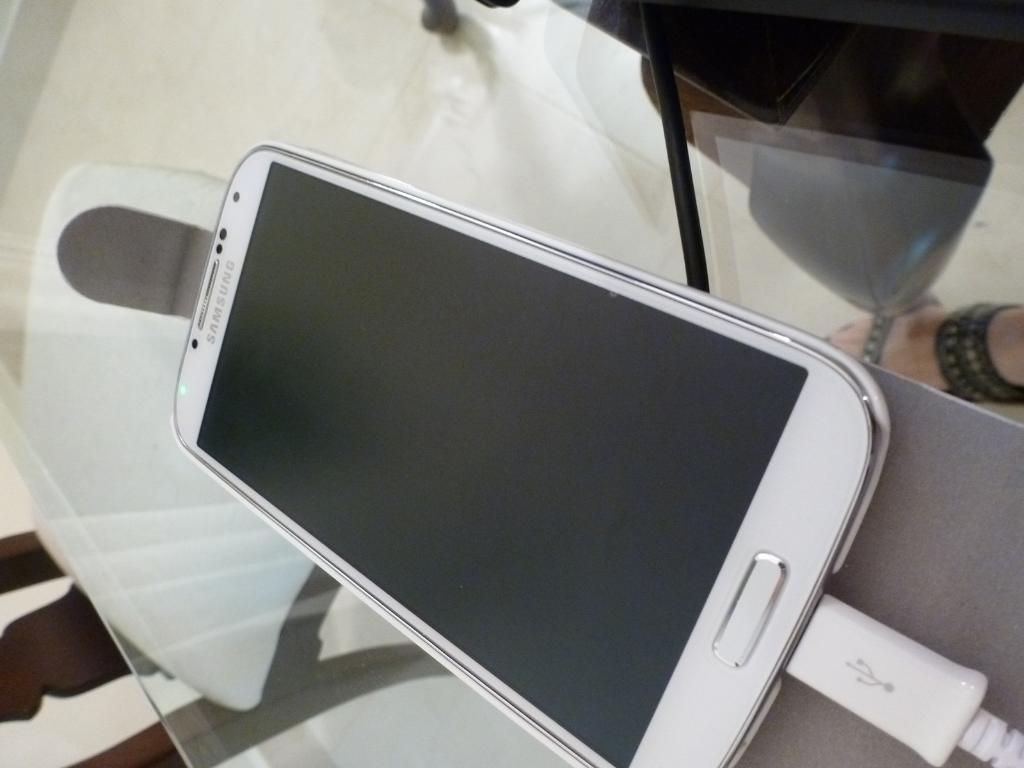Could you give a brief overview of what you see in this image? This image consists of a mobile kept for charging. The mobile is in white color. To the right, there is a leg of a person. The mobile is kept on a table. At the bottom, there is floor. 